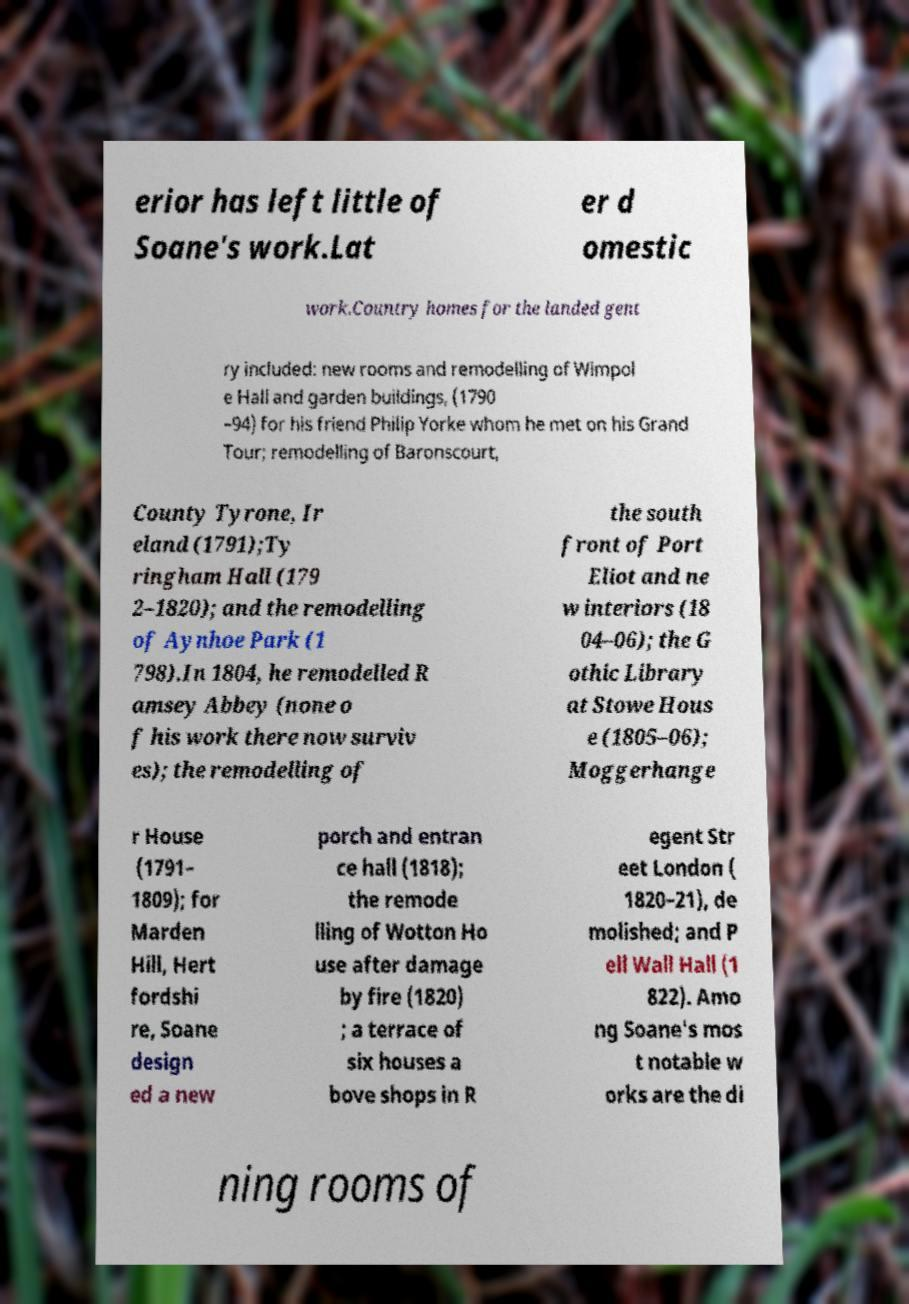Could you assist in decoding the text presented in this image and type it out clearly? erior has left little of Soane's work.Lat er d omestic work.Country homes for the landed gent ry included: new rooms and remodelling of Wimpol e Hall and garden buildings, (1790 –94) for his friend Philip Yorke whom he met on his Grand Tour; remodelling of Baronscourt, County Tyrone, Ir eland (1791);Ty ringham Hall (179 2–1820); and the remodelling of Aynhoe Park (1 798).In 1804, he remodelled R amsey Abbey (none o f his work there now surviv es); the remodelling of the south front of Port Eliot and ne w interiors (18 04–06); the G othic Library at Stowe Hous e (1805–06); Moggerhange r House (1791– 1809); for Marden Hill, Hert fordshi re, Soane design ed a new porch and entran ce hall (1818); the remode lling of Wotton Ho use after damage by fire (1820) ; a terrace of six houses a bove shops in R egent Str eet London ( 1820–21), de molished; and P ell Wall Hall (1 822). Amo ng Soane's mos t notable w orks are the di ning rooms of 